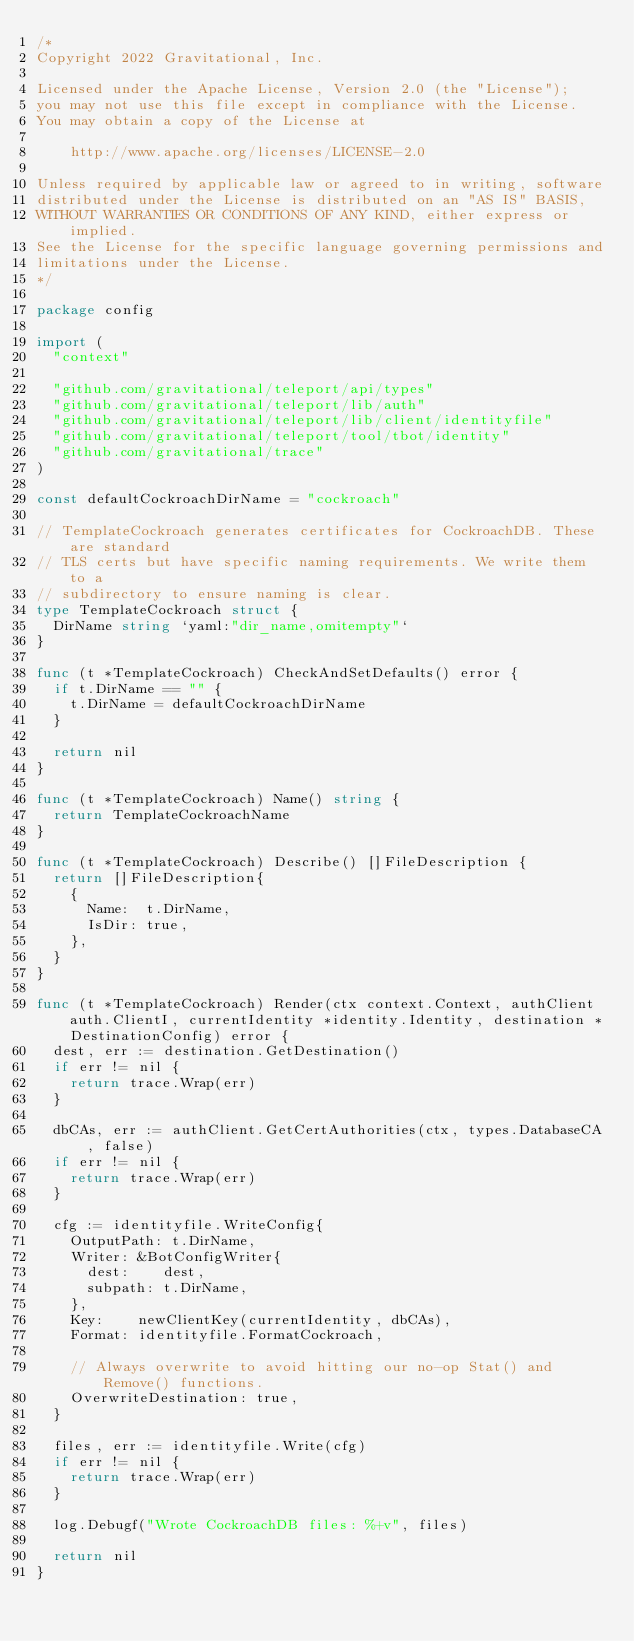<code> <loc_0><loc_0><loc_500><loc_500><_Go_>/*
Copyright 2022 Gravitational, Inc.

Licensed under the Apache License, Version 2.0 (the "License");
you may not use this file except in compliance with the License.
You may obtain a copy of the License at

    http://www.apache.org/licenses/LICENSE-2.0

Unless required by applicable law or agreed to in writing, software
distributed under the License is distributed on an "AS IS" BASIS,
WITHOUT WARRANTIES OR CONDITIONS OF ANY KIND, either express or implied.
See the License for the specific language governing permissions and
limitations under the License.
*/

package config

import (
	"context"

	"github.com/gravitational/teleport/api/types"
	"github.com/gravitational/teleport/lib/auth"
	"github.com/gravitational/teleport/lib/client/identityfile"
	"github.com/gravitational/teleport/tool/tbot/identity"
	"github.com/gravitational/trace"
)

const defaultCockroachDirName = "cockroach"

// TemplateCockroach generates certificates for CockroachDB. These are standard
// TLS certs but have specific naming requirements. We write them to a
// subdirectory to ensure naming is clear.
type TemplateCockroach struct {
	DirName string `yaml:"dir_name,omitempty"`
}

func (t *TemplateCockroach) CheckAndSetDefaults() error {
	if t.DirName == "" {
		t.DirName = defaultCockroachDirName
	}

	return nil
}

func (t *TemplateCockroach) Name() string {
	return TemplateCockroachName
}

func (t *TemplateCockroach) Describe() []FileDescription {
	return []FileDescription{
		{
			Name:  t.DirName,
			IsDir: true,
		},
	}
}

func (t *TemplateCockroach) Render(ctx context.Context, authClient auth.ClientI, currentIdentity *identity.Identity, destination *DestinationConfig) error {
	dest, err := destination.GetDestination()
	if err != nil {
		return trace.Wrap(err)
	}

	dbCAs, err := authClient.GetCertAuthorities(ctx, types.DatabaseCA, false)
	if err != nil {
		return trace.Wrap(err)
	}

	cfg := identityfile.WriteConfig{
		OutputPath: t.DirName,
		Writer: &BotConfigWriter{
			dest:    dest,
			subpath: t.DirName,
		},
		Key:    newClientKey(currentIdentity, dbCAs),
		Format: identityfile.FormatCockroach,

		// Always overwrite to avoid hitting our no-op Stat() and Remove() functions.
		OverwriteDestination: true,
	}

	files, err := identityfile.Write(cfg)
	if err != nil {
		return trace.Wrap(err)
	}

	log.Debugf("Wrote CockroachDB files: %+v", files)

	return nil
}
</code> 